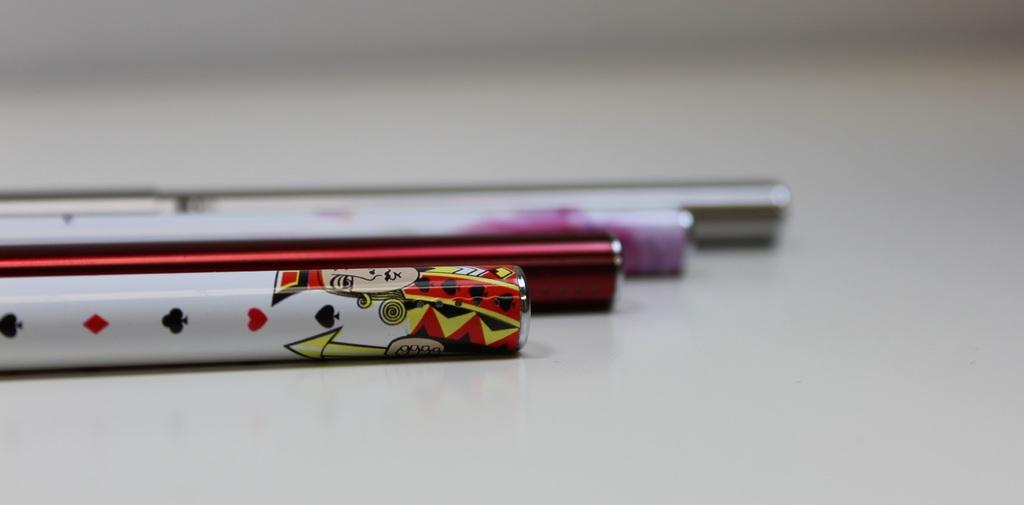What can be observed in the image? There are multiple things in the image. Can you describe one of the items in the image? One of the things features a cartoon character. What color is a significant part of the image? The white color surface is present in the image. What word does the judge use to reward the cartoon character in the image? There is no judge or reward mentioned in the image, as it only features multiple things, including one with a cartoon character. 